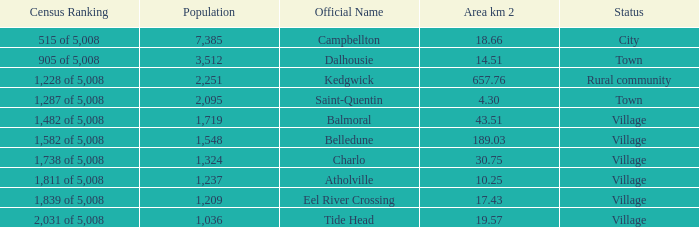When the status is rural community what's the lowest area in kilometers squared? 657.76. 